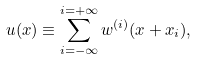<formula> <loc_0><loc_0><loc_500><loc_500>u ( x ) \equiv \sum _ { i = - \infty } ^ { i = + \infty } w ^ { ( i ) } ( x + x _ { i } ) ,</formula> 